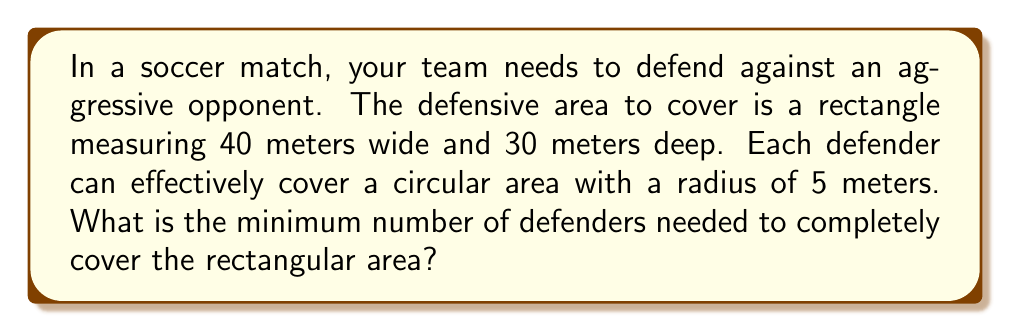Help me with this question. Let's approach this step-by-step:

1) First, we need to calculate the area of the rectangle:
   $A_{rectangle} = 40m \times 30m = 1200m^2$

2) Next, we calculate the area that each defender can cover:
   $A_{defender} = \pi r^2 = \pi \times 5^2 = 25\pi m^2$

3) To find the minimum number of defenders, we divide the total area by the area each defender can cover and round up to the nearest whole number:

   $\text{Minimum defenders} = \left\lceil\frac{A_{rectangle}}{A_{defender}}\right\rceil$

   $= \left\lceil\frac{1200}{25\pi}\right\rceil$

4) Let's calculate this:
   $\frac{1200}{25\pi} \approx 15.2788$

5) Rounding up, we get 16.

Therefore, the minimum number of defenders needed is 16.

Note: This is a theoretical minimum. In practice, you might need more defenders due to the circular coverage areas not perfectly fitting the rectangular field without overlap.
Answer: 16 defenders 